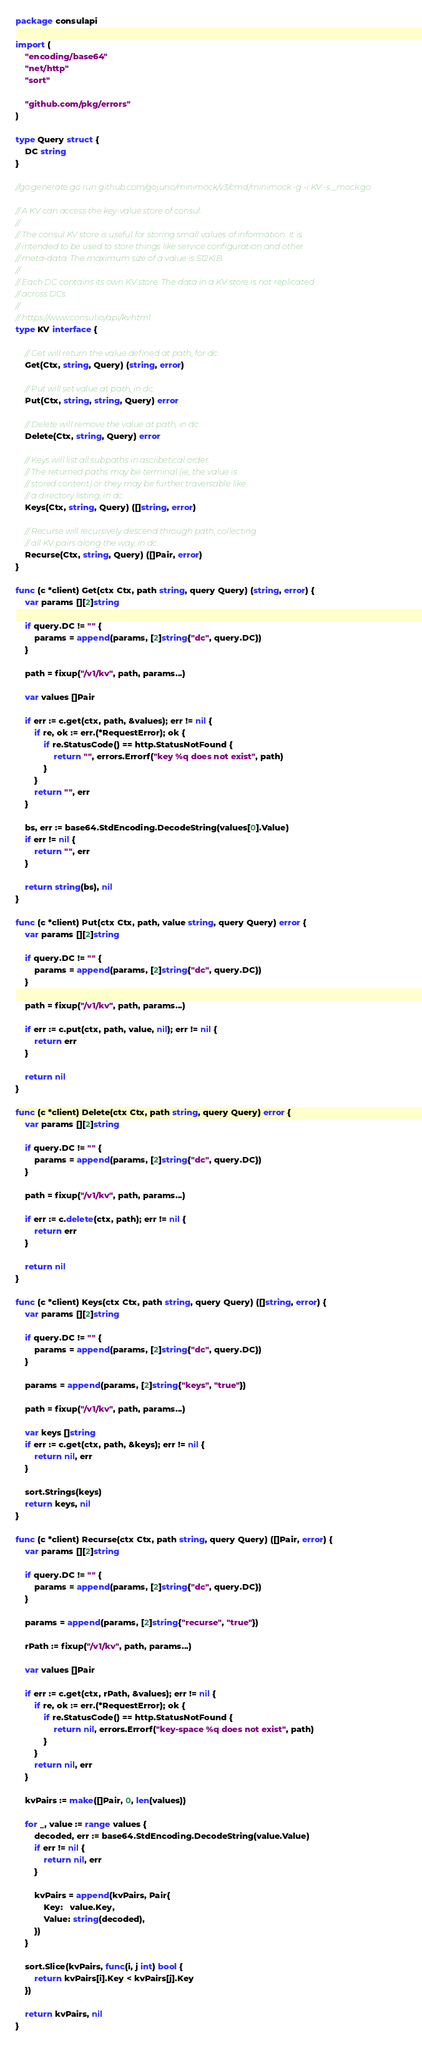<code> <loc_0><loc_0><loc_500><loc_500><_Go_>package consulapi

import (
	"encoding/base64"
	"net/http"
	"sort"

	"github.com/pkg/errors"
)

type Query struct {
	DC string
}

//go:generate go run github.com/gojuno/minimock/v3/cmd/minimock -g -i KV -s _mock.go

// A KV can access the key-value store of consul.
//
// The consul KV store is useful for storing small values of information. It is
// intended to be used to store things like service configuration and other
// meta-data. The maximum size of a value is 512KiB.
//
// Each DC contains its own KV store. The data in a KV store is not replicated
// across DCs.
//
// https://www.consul.io/api/kv.html
type KV interface {

	// Get will return the value defined at path, for dc.
	Get(Ctx, string, Query) (string, error)

	// Put will set value at path, in dc.
	Put(Ctx, string, string, Query) error

	// Delete will remove the value at path, in dc.
	Delete(Ctx, string, Query) error

	// Keys will list all subpaths in asciibetical order.
	// The returned paths may be terminal (ie, the value is
	// stored content) or they may be further traversable like
	// a directory listing, in dc.
	Keys(Ctx, string, Query) ([]string, error)

	// Recurse will recursively descend through path, collecting
	// all KV pairs along the way, in dc.
	Recurse(Ctx, string, Query) ([]Pair, error)
}

func (c *client) Get(ctx Ctx, path string, query Query) (string, error) {
	var params [][2]string

	if query.DC != "" {
		params = append(params, [2]string{"dc", query.DC})
	}

	path = fixup("/v1/kv", path, params...)

	var values []Pair

	if err := c.get(ctx, path, &values); err != nil {
		if re, ok := err.(*RequestError); ok {
			if re.StatusCode() == http.StatusNotFound {
				return "", errors.Errorf("key %q does not exist", path)
			}
		}
		return "", err
	}

	bs, err := base64.StdEncoding.DecodeString(values[0].Value)
	if err != nil {
		return "", err
	}

	return string(bs), nil
}

func (c *client) Put(ctx Ctx, path, value string, query Query) error {
	var params [][2]string

	if query.DC != "" {
		params = append(params, [2]string{"dc", query.DC})
	}

	path = fixup("/v1/kv", path, params...)

	if err := c.put(ctx, path, value, nil); err != nil {
		return err
	}

	return nil
}

func (c *client) Delete(ctx Ctx, path string, query Query) error {
	var params [][2]string

	if query.DC != "" {
		params = append(params, [2]string{"dc", query.DC})
	}

	path = fixup("/v1/kv", path, params...)

	if err := c.delete(ctx, path); err != nil {
		return err
	}

	return nil
}

func (c *client) Keys(ctx Ctx, path string, query Query) ([]string, error) {
	var params [][2]string

	if query.DC != "" {
		params = append(params, [2]string{"dc", query.DC})
	}

	params = append(params, [2]string{"keys", "true"})

	path = fixup("/v1/kv", path, params...)

	var keys []string
	if err := c.get(ctx, path, &keys); err != nil {
		return nil, err
	}

	sort.Strings(keys)
	return keys, nil
}

func (c *client) Recurse(ctx Ctx, path string, query Query) ([]Pair, error) {
	var params [][2]string

	if query.DC != "" {
		params = append(params, [2]string{"dc", query.DC})
	}

	params = append(params, [2]string{"recurse", "true"})

	rPath := fixup("/v1/kv", path, params...)

	var values []Pair

	if err := c.get(ctx, rPath, &values); err != nil {
		if re, ok := err.(*RequestError); ok {
			if re.StatusCode() == http.StatusNotFound {
				return nil, errors.Errorf("key-space %q does not exist", path)
			}
		}
		return nil, err
	}

	kvPairs := make([]Pair, 0, len(values))

	for _, value := range values {
		decoded, err := base64.StdEncoding.DecodeString(value.Value)
		if err != nil {
			return nil, err
		}

		kvPairs = append(kvPairs, Pair{
			Key:   value.Key,
			Value: string(decoded),
		})
	}

	sort.Slice(kvPairs, func(i, j int) bool {
		return kvPairs[i].Key < kvPairs[j].Key
	})

	return kvPairs, nil
}
</code> 